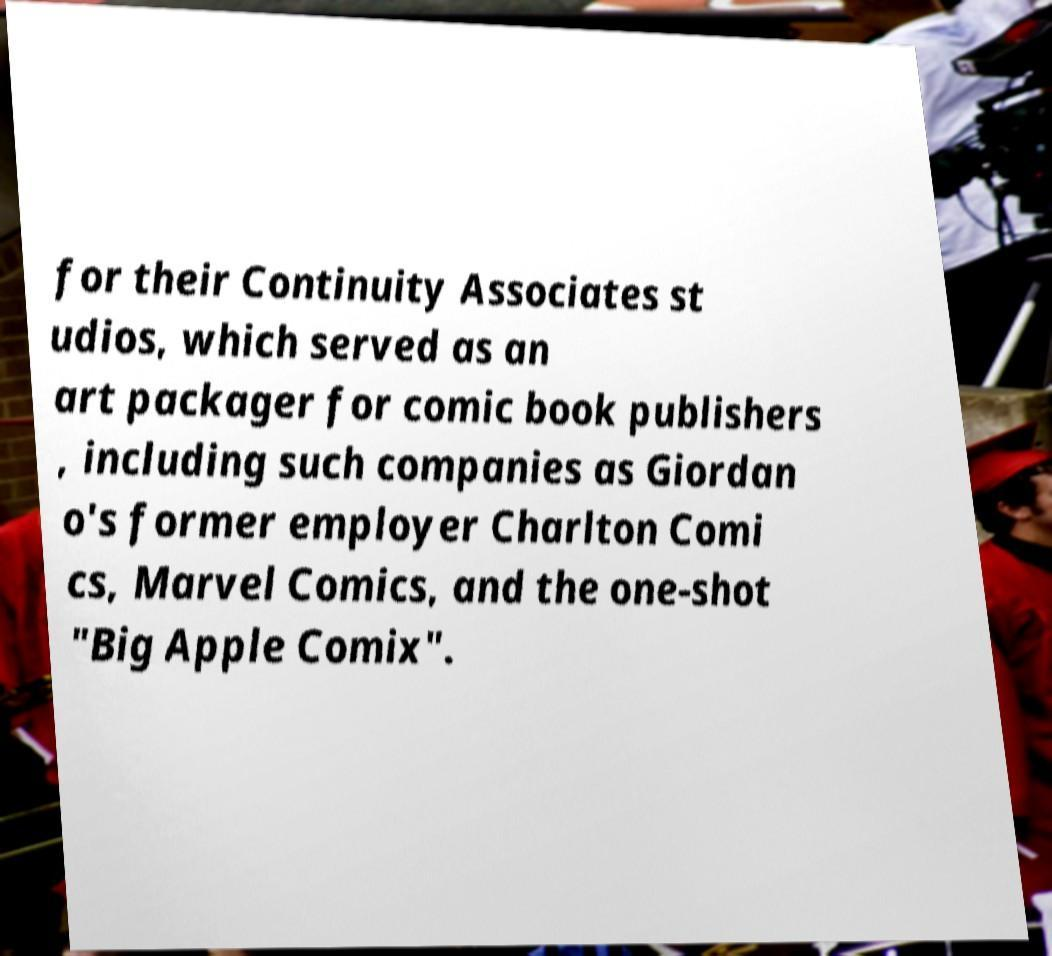Please read and relay the text visible in this image. What does it say? for their Continuity Associates st udios, which served as an art packager for comic book publishers , including such companies as Giordan o's former employer Charlton Comi cs, Marvel Comics, and the one-shot "Big Apple Comix". 